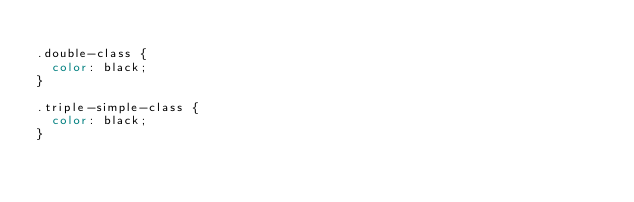<code> <loc_0><loc_0><loc_500><loc_500><_CSS_>
.double-class {
  color: black;
}

.triple-simple-class {
  color: black;
}</code> 